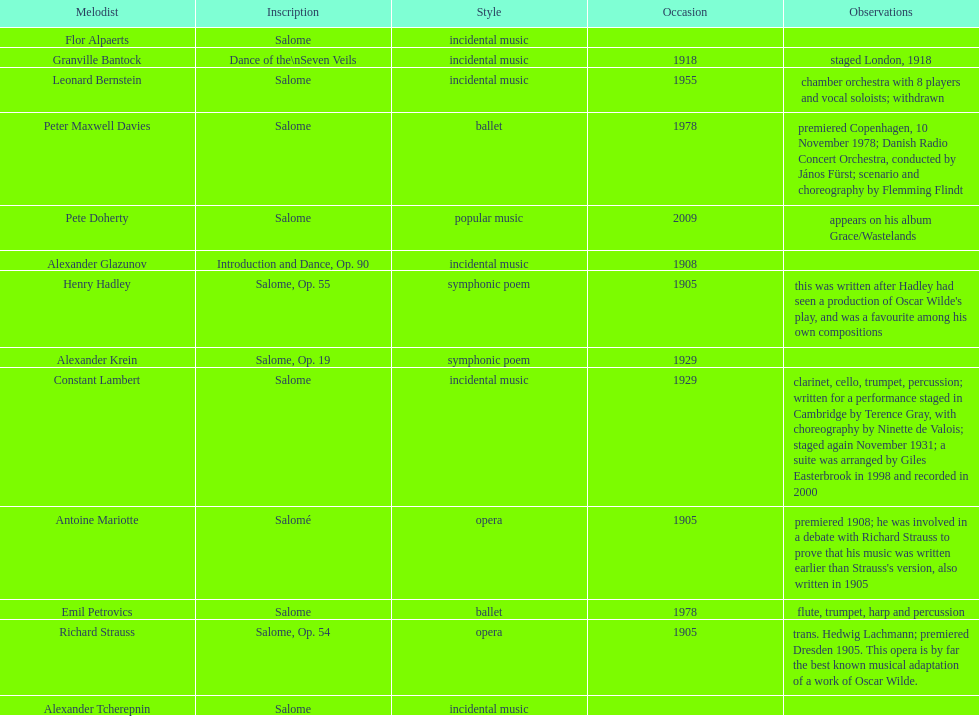Which composer is listed below pete doherty? Alexander Glazunov. Could you help me parse every detail presented in this table? {'header': ['Melodist', 'Inscription', 'Style', 'Occasion', 'Observations'], 'rows': [['Flor Alpaerts', 'Salome', 'incidental\xa0music', '', ''], ['Granville Bantock', 'Dance of the\\nSeven Veils', 'incidental music', '1918', 'staged London, 1918'], ['Leonard Bernstein', 'Salome', 'incidental music', '1955', 'chamber orchestra with 8 players and vocal soloists; withdrawn'], ['Peter\xa0Maxwell\xa0Davies', 'Salome', 'ballet', '1978', 'premiered Copenhagen, 10 November 1978; Danish Radio Concert Orchestra, conducted by János Fürst; scenario and choreography by Flemming Flindt'], ['Pete Doherty', 'Salome', 'popular music', '2009', 'appears on his album Grace/Wastelands'], ['Alexander Glazunov', 'Introduction and Dance, Op. 90', 'incidental music', '1908', ''], ['Henry Hadley', 'Salome, Op. 55', 'symphonic poem', '1905', "this was written after Hadley had seen a production of Oscar Wilde's play, and was a favourite among his own compositions"], ['Alexander Krein', 'Salome, Op. 19', 'symphonic poem', '1929', ''], ['Constant Lambert', 'Salome', 'incidental music', '1929', 'clarinet, cello, trumpet, percussion; written for a performance staged in Cambridge by Terence Gray, with choreography by Ninette de Valois; staged again November 1931; a suite was arranged by Giles Easterbrook in 1998 and recorded in 2000'], ['Antoine Mariotte', 'Salomé', 'opera', '1905', "premiered 1908; he was involved in a debate with Richard Strauss to prove that his music was written earlier than Strauss's version, also written in 1905"], ['Emil Petrovics', 'Salome', 'ballet', '1978', 'flute, trumpet, harp and percussion'], ['Richard Strauss', 'Salome, Op. 54', 'opera', '1905', 'trans. Hedwig Lachmann; premiered Dresden 1905. This opera is by far the best known musical adaptation of a work of Oscar Wilde.'], ['Alexander\xa0Tcherepnin', 'Salome', 'incidental music', '', '']]} 